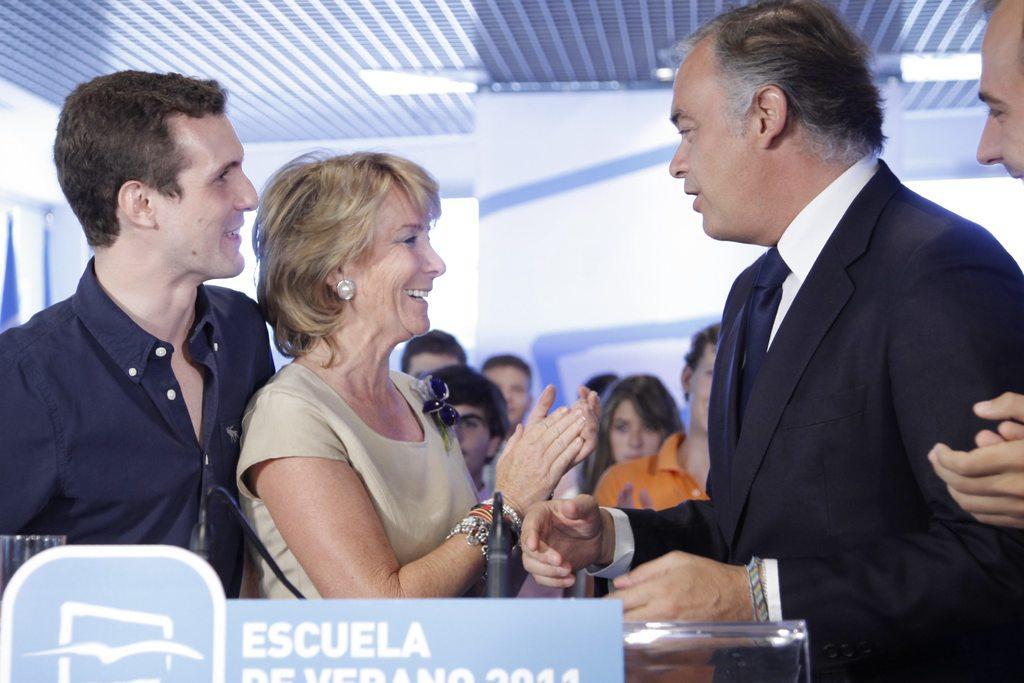Please provide a concise description of this image. In this image I can see on the left side a man is smiling. He wore black color shirt. In the middle a woman is smiling, on the right side a man is talking. He wore coat, tie, shirt. In the middle few people are there at the bottom there is the board. 